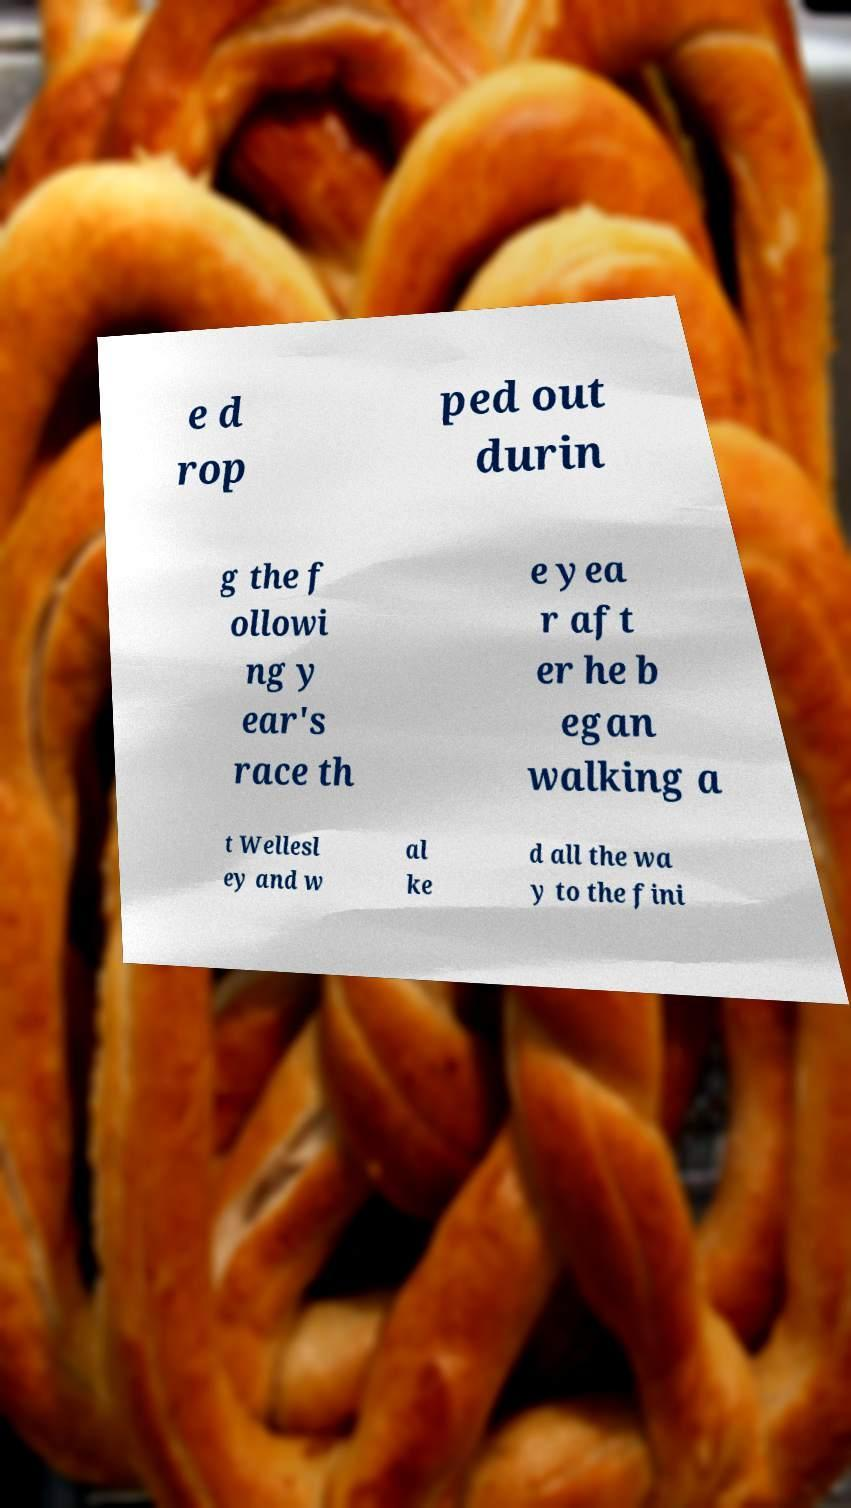Please identify and transcribe the text found in this image. e d rop ped out durin g the f ollowi ng y ear's race th e yea r aft er he b egan walking a t Wellesl ey and w al ke d all the wa y to the fini 